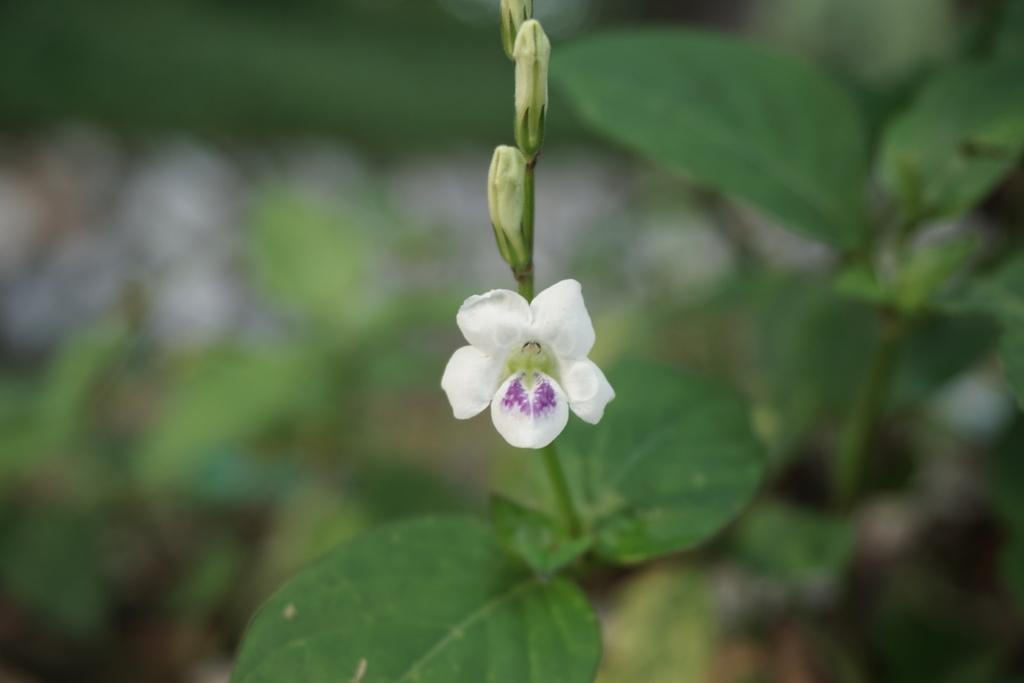Can you describe this image briefly? In the foreground of this picture, there is a white flower to a plant we can also see few buds to it. In the background, there are plants blurred. 